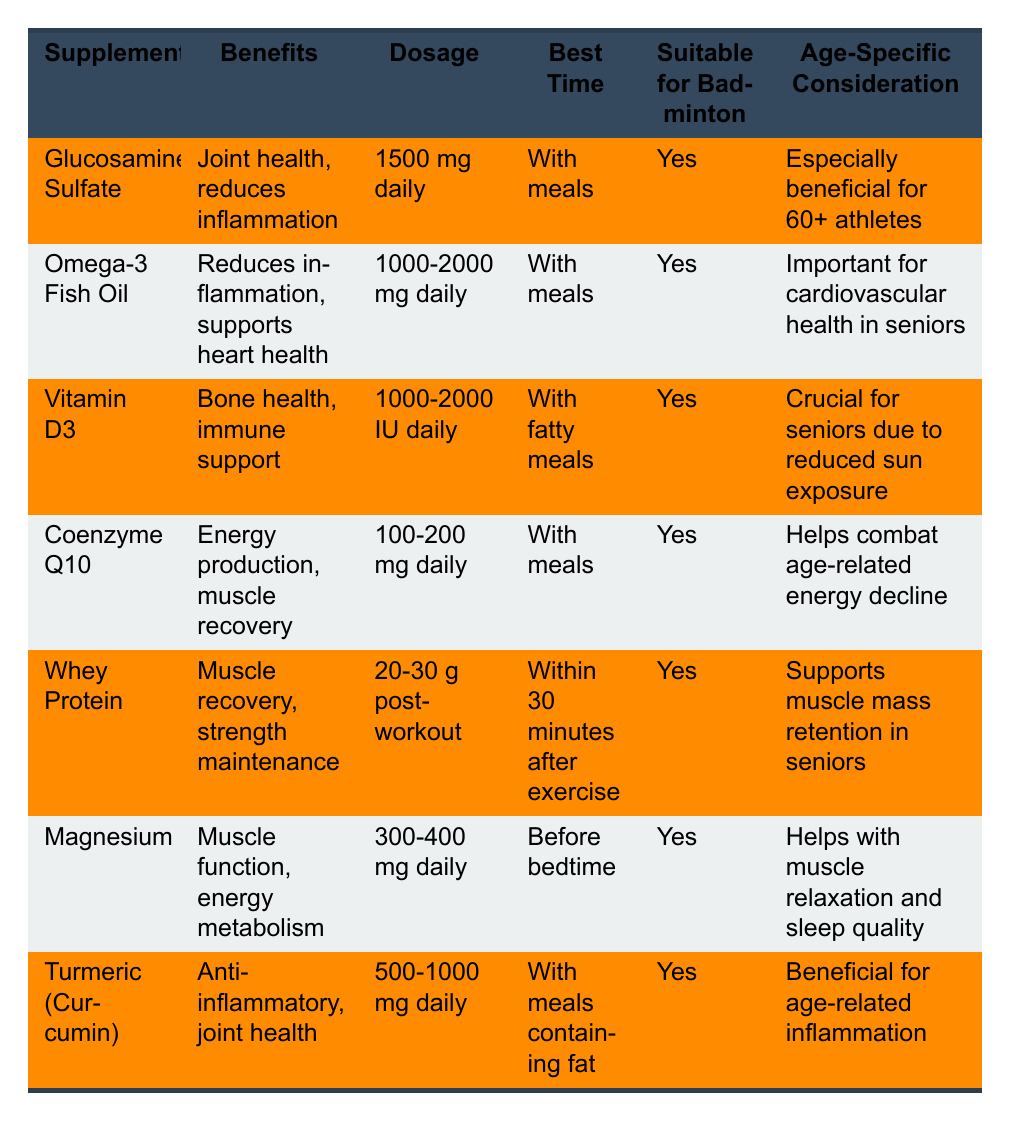What are the benefits of Omega-3 Fish Oil? According to the table, the benefits of Omega-3 Fish Oil are "Reduces inflammation, supports heart health."
Answer: Reduces inflammation, supports heart health What is the recommended dosage of Whey Protein? The table states that the recommended dosage of Whey Protein is "20-30 g post-workout."
Answer: 20-30 g post-workout Is Magnesium suitable for badminton players? The table indicates that Magnesium is listed as "Yes" under the column "Suitable for Badminton."
Answer: Yes Which supplement is especially beneficial for 60+ athletes? The table shows that Glucosamine Sulfate has the note "Especially beneficial for 60+ athletes."
Answer: Glucosamine Sulfate What is the recommended dosage range for Vitamin D3? From the table, the recommended dosage range for Vitamin D3 is "1000-2000 IU daily."
Answer: 1000-2000 IU daily How many supplements have joint health benefits? The table shows that both Glucosamine Sulfate and Turmeric have benefits related to joint health. This is a total of 2 supplements.
Answer: 2 Is Coenzyme Q10 beneficial for energy production? The table states that one of the benefits of Coenzyme Q10 is "Energy production."
Answer: Yes What is the average recommended dosage of Omega-3 Fish Oil and Vitamin D3 combined? The recommended dosage for Omega-3 Fish Oil is "1000-2000 mg daily" and for Vitamin D3 is "1000-2000 IU daily". To average these dosages: Omega-3 average is (1000 + 2000) / 2 = 1500 mg, and Vitamin D3 average is (1000 + 2000) / 2 = 1500 IU. Therefore, the average combined dosage would be (1500 + 1500) / 2 = 1500.
Answer: 1500 What supplement should be taken with fatty meals? The table indicates that Vitamin D3 should be taken "With fatty meals."
Answer: Vitamin D3 